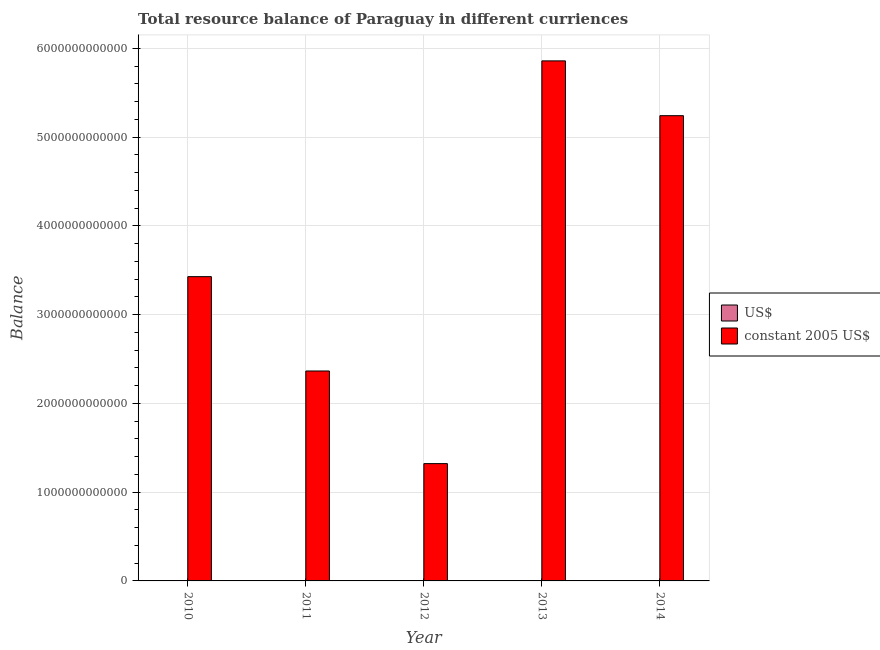How many different coloured bars are there?
Your answer should be compact. 2. How many groups of bars are there?
Provide a short and direct response. 5. Are the number of bars per tick equal to the number of legend labels?
Ensure brevity in your answer.  Yes. How many bars are there on the 1st tick from the right?
Provide a short and direct response. 2. What is the resource balance in us$ in 2011?
Ensure brevity in your answer.  5.64e+08. Across all years, what is the maximum resource balance in constant us$?
Keep it short and to the point. 5.86e+12. Across all years, what is the minimum resource balance in constant us$?
Give a very brief answer. 1.32e+12. What is the total resource balance in us$ in the graph?
Offer a very short reply. 4.12e+09. What is the difference between the resource balance in us$ in 2010 and that in 2013?
Your response must be concise. -6.38e+08. What is the difference between the resource balance in constant us$ in 2014 and the resource balance in us$ in 2010?
Offer a terse response. 1.81e+12. What is the average resource balance in us$ per year?
Your answer should be compact. 8.24e+08. In the year 2013, what is the difference between the resource balance in us$ and resource balance in constant us$?
Make the answer very short. 0. What is the ratio of the resource balance in constant us$ in 2010 to that in 2012?
Make the answer very short. 2.59. What is the difference between the highest and the second highest resource balance in us$?
Make the answer very short. 1.87e+08. What is the difference between the highest and the lowest resource balance in us$?
Offer a terse response. 1.06e+09. What does the 2nd bar from the left in 2013 represents?
Your answer should be compact. Constant 2005 us$. What does the 1st bar from the right in 2012 represents?
Keep it short and to the point. Constant 2005 us$. Are all the bars in the graph horizontal?
Ensure brevity in your answer.  No. How many years are there in the graph?
Make the answer very short. 5. What is the difference between two consecutive major ticks on the Y-axis?
Your response must be concise. 1.00e+12. Does the graph contain any zero values?
Provide a short and direct response. No. How are the legend labels stacked?
Make the answer very short. Vertical. What is the title of the graph?
Your answer should be compact. Total resource balance of Paraguay in different curriences. What is the label or title of the X-axis?
Keep it short and to the point. Year. What is the label or title of the Y-axis?
Offer a terse response. Balance. What is the Balance of US$ in 2010?
Make the answer very short. 7.23e+08. What is the Balance of constant 2005 US$ in 2010?
Provide a short and direct response. 3.43e+12. What is the Balance in US$ in 2011?
Keep it short and to the point. 5.64e+08. What is the Balance of constant 2005 US$ in 2011?
Give a very brief answer. 2.37e+12. What is the Balance in US$ in 2012?
Your answer should be very brief. 2.99e+08. What is the Balance of constant 2005 US$ in 2012?
Offer a terse response. 1.32e+12. What is the Balance in US$ in 2013?
Ensure brevity in your answer.  1.36e+09. What is the Balance in constant 2005 US$ in 2013?
Your answer should be very brief. 5.86e+12. What is the Balance of US$ in 2014?
Your answer should be compact. 1.17e+09. What is the Balance in constant 2005 US$ in 2014?
Offer a very short reply. 5.24e+12. Across all years, what is the maximum Balance in US$?
Keep it short and to the point. 1.36e+09. Across all years, what is the maximum Balance of constant 2005 US$?
Keep it short and to the point. 5.86e+12. Across all years, what is the minimum Balance of US$?
Your answer should be compact. 2.99e+08. Across all years, what is the minimum Balance of constant 2005 US$?
Provide a short and direct response. 1.32e+12. What is the total Balance in US$ in the graph?
Give a very brief answer. 4.12e+09. What is the total Balance in constant 2005 US$ in the graph?
Give a very brief answer. 1.82e+13. What is the difference between the Balance in US$ in 2010 and that in 2011?
Keep it short and to the point. 1.60e+08. What is the difference between the Balance in constant 2005 US$ in 2010 and that in 2011?
Give a very brief answer. 1.06e+12. What is the difference between the Balance in US$ in 2010 and that in 2012?
Make the answer very short. 4.25e+08. What is the difference between the Balance in constant 2005 US$ in 2010 and that in 2012?
Provide a short and direct response. 2.11e+12. What is the difference between the Balance of US$ in 2010 and that in 2013?
Offer a very short reply. -6.38e+08. What is the difference between the Balance in constant 2005 US$ in 2010 and that in 2013?
Give a very brief answer. -2.43e+12. What is the difference between the Balance in US$ in 2010 and that in 2014?
Offer a very short reply. -4.51e+08. What is the difference between the Balance in constant 2005 US$ in 2010 and that in 2014?
Provide a short and direct response. -1.81e+12. What is the difference between the Balance in US$ in 2011 and that in 2012?
Offer a very short reply. 2.65e+08. What is the difference between the Balance of constant 2005 US$ in 2011 and that in 2012?
Keep it short and to the point. 1.04e+12. What is the difference between the Balance in US$ in 2011 and that in 2013?
Your answer should be compact. -7.98e+08. What is the difference between the Balance of constant 2005 US$ in 2011 and that in 2013?
Provide a succinct answer. -3.49e+12. What is the difference between the Balance in US$ in 2011 and that in 2014?
Provide a short and direct response. -6.11e+08. What is the difference between the Balance of constant 2005 US$ in 2011 and that in 2014?
Give a very brief answer. -2.88e+12. What is the difference between the Balance of US$ in 2012 and that in 2013?
Your response must be concise. -1.06e+09. What is the difference between the Balance in constant 2005 US$ in 2012 and that in 2013?
Your answer should be compact. -4.54e+12. What is the difference between the Balance of US$ in 2012 and that in 2014?
Your answer should be very brief. -8.76e+08. What is the difference between the Balance in constant 2005 US$ in 2012 and that in 2014?
Provide a short and direct response. -3.92e+12. What is the difference between the Balance of US$ in 2013 and that in 2014?
Offer a very short reply. 1.87e+08. What is the difference between the Balance in constant 2005 US$ in 2013 and that in 2014?
Give a very brief answer. 6.17e+11. What is the difference between the Balance in US$ in 2010 and the Balance in constant 2005 US$ in 2011?
Offer a terse response. -2.36e+12. What is the difference between the Balance in US$ in 2010 and the Balance in constant 2005 US$ in 2012?
Make the answer very short. -1.32e+12. What is the difference between the Balance in US$ in 2010 and the Balance in constant 2005 US$ in 2013?
Provide a succinct answer. -5.86e+12. What is the difference between the Balance in US$ in 2010 and the Balance in constant 2005 US$ in 2014?
Your response must be concise. -5.24e+12. What is the difference between the Balance of US$ in 2011 and the Balance of constant 2005 US$ in 2012?
Your answer should be very brief. -1.32e+12. What is the difference between the Balance of US$ in 2011 and the Balance of constant 2005 US$ in 2013?
Your answer should be compact. -5.86e+12. What is the difference between the Balance in US$ in 2011 and the Balance in constant 2005 US$ in 2014?
Make the answer very short. -5.24e+12. What is the difference between the Balance in US$ in 2012 and the Balance in constant 2005 US$ in 2013?
Your response must be concise. -5.86e+12. What is the difference between the Balance of US$ in 2012 and the Balance of constant 2005 US$ in 2014?
Your response must be concise. -5.24e+12. What is the difference between the Balance of US$ in 2013 and the Balance of constant 2005 US$ in 2014?
Provide a short and direct response. -5.24e+12. What is the average Balance in US$ per year?
Give a very brief answer. 8.24e+08. What is the average Balance of constant 2005 US$ per year?
Provide a succinct answer. 3.64e+12. In the year 2010, what is the difference between the Balance in US$ and Balance in constant 2005 US$?
Give a very brief answer. -3.43e+12. In the year 2011, what is the difference between the Balance of US$ and Balance of constant 2005 US$?
Your response must be concise. -2.36e+12. In the year 2012, what is the difference between the Balance of US$ and Balance of constant 2005 US$?
Make the answer very short. -1.32e+12. In the year 2013, what is the difference between the Balance in US$ and Balance in constant 2005 US$?
Provide a succinct answer. -5.86e+12. In the year 2014, what is the difference between the Balance in US$ and Balance in constant 2005 US$?
Your response must be concise. -5.24e+12. What is the ratio of the Balance in US$ in 2010 to that in 2011?
Offer a very short reply. 1.28. What is the ratio of the Balance in constant 2005 US$ in 2010 to that in 2011?
Ensure brevity in your answer.  1.45. What is the ratio of the Balance of US$ in 2010 to that in 2012?
Your answer should be compact. 2.42. What is the ratio of the Balance of constant 2005 US$ in 2010 to that in 2012?
Keep it short and to the point. 2.59. What is the ratio of the Balance of US$ in 2010 to that in 2013?
Provide a short and direct response. 0.53. What is the ratio of the Balance in constant 2005 US$ in 2010 to that in 2013?
Your response must be concise. 0.59. What is the ratio of the Balance in US$ in 2010 to that in 2014?
Ensure brevity in your answer.  0.62. What is the ratio of the Balance in constant 2005 US$ in 2010 to that in 2014?
Make the answer very short. 0.65. What is the ratio of the Balance in US$ in 2011 to that in 2012?
Provide a short and direct response. 1.89. What is the ratio of the Balance in constant 2005 US$ in 2011 to that in 2012?
Your answer should be compact. 1.79. What is the ratio of the Balance in US$ in 2011 to that in 2013?
Your response must be concise. 0.41. What is the ratio of the Balance of constant 2005 US$ in 2011 to that in 2013?
Offer a very short reply. 0.4. What is the ratio of the Balance of US$ in 2011 to that in 2014?
Your answer should be compact. 0.48. What is the ratio of the Balance of constant 2005 US$ in 2011 to that in 2014?
Ensure brevity in your answer.  0.45. What is the ratio of the Balance of US$ in 2012 to that in 2013?
Provide a short and direct response. 0.22. What is the ratio of the Balance in constant 2005 US$ in 2012 to that in 2013?
Give a very brief answer. 0.23. What is the ratio of the Balance of US$ in 2012 to that in 2014?
Your response must be concise. 0.25. What is the ratio of the Balance of constant 2005 US$ in 2012 to that in 2014?
Make the answer very short. 0.25. What is the ratio of the Balance of US$ in 2013 to that in 2014?
Your answer should be very brief. 1.16. What is the ratio of the Balance of constant 2005 US$ in 2013 to that in 2014?
Your answer should be compact. 1.12. What is the difference between the highest and the second highest Balance of US$?
Provide a short and direct response. 1.87e+08. What is the difference between the highest and the second highest Balance in constant 2005 US$?
Offer a very short reply. 6.17e+11. What is the difference between the highest and the lowest Balance of US$?
Provide a succinct answer. 1.06e+09. What is the difference between the highest and the lowest Balance of constant 2005 US$?
Provide a succinct answer. 4.54e+12. 